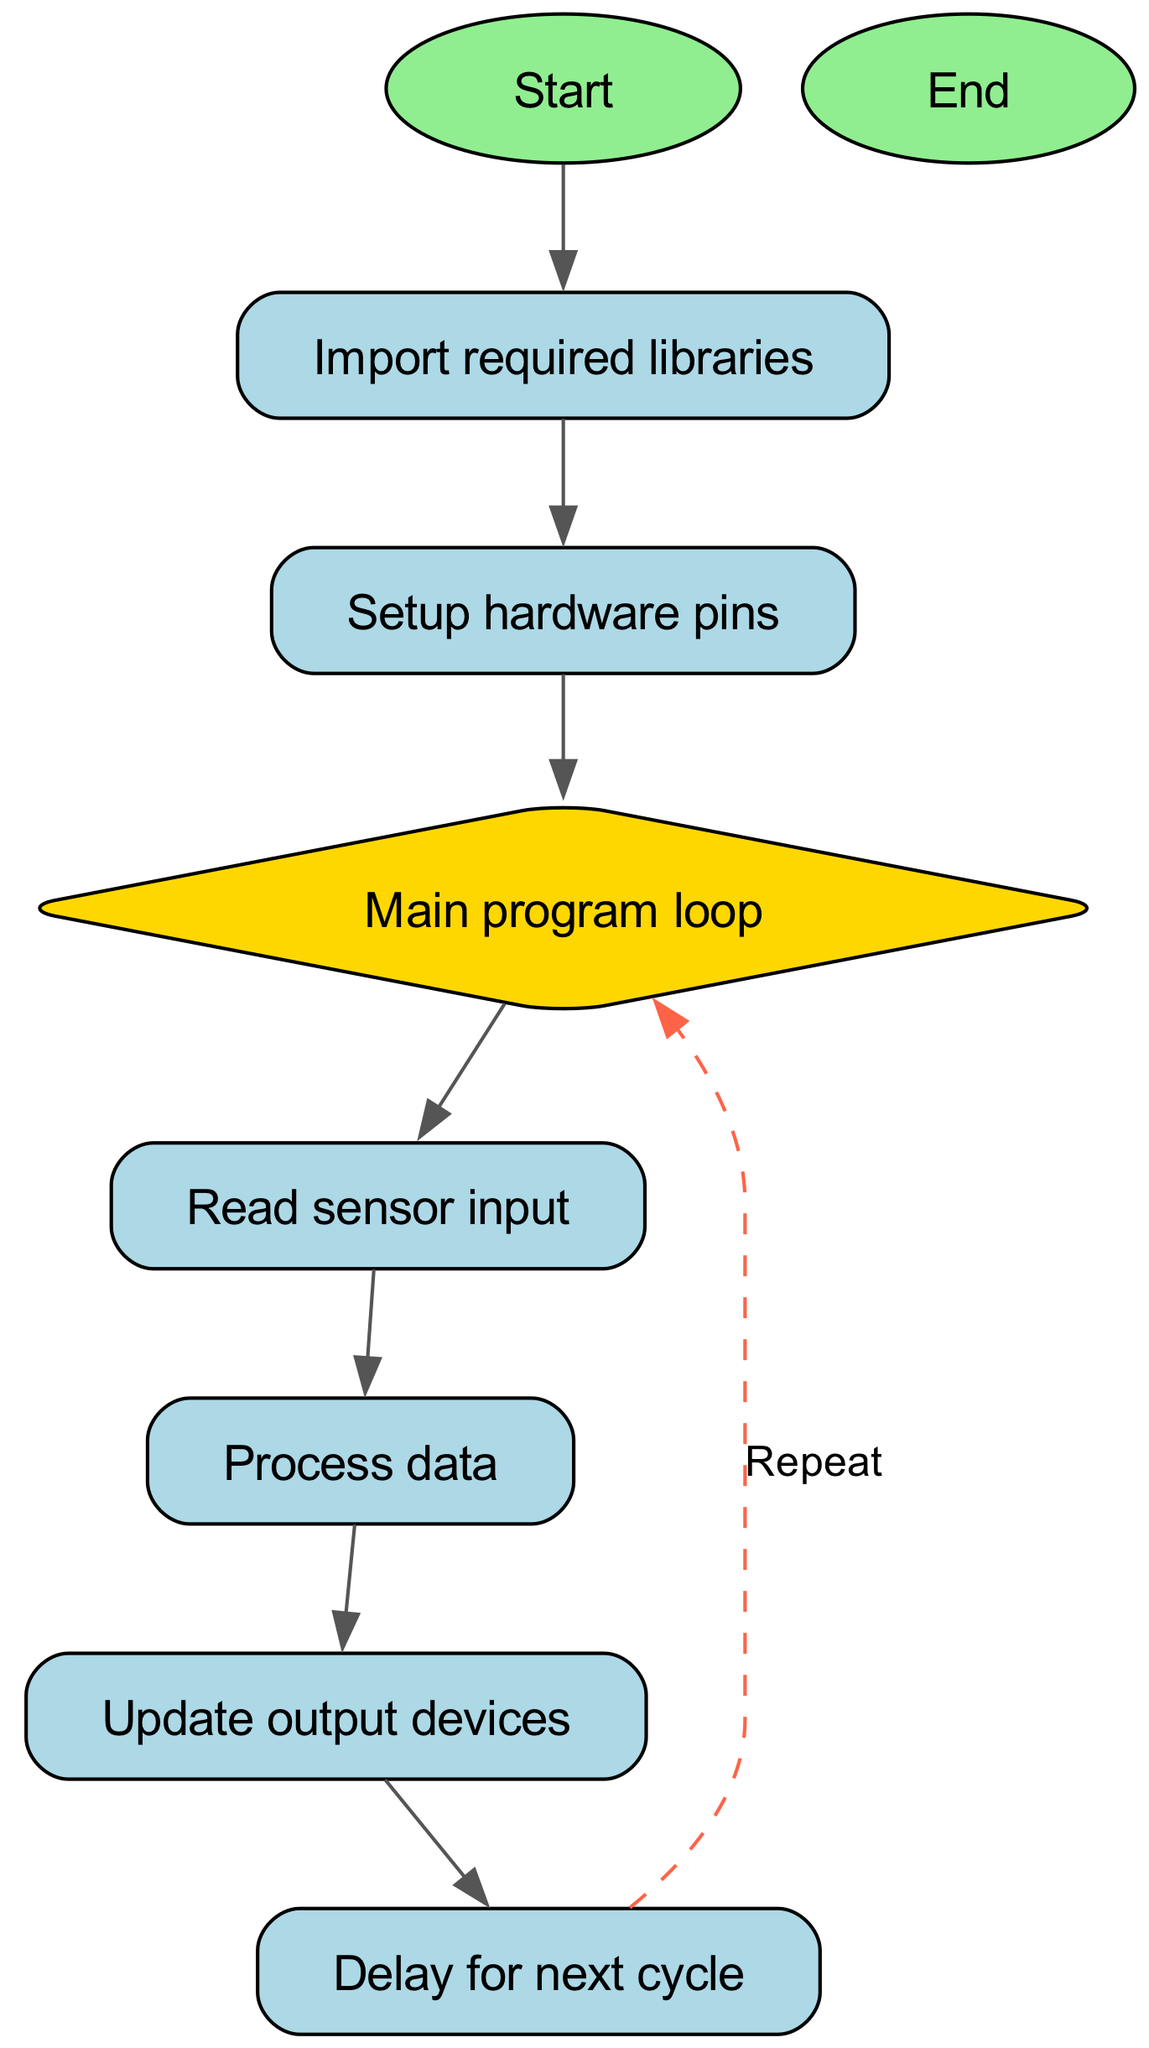What is the first step in the MicroPython program flow? The first step is represented by the node labeled "Start." It initiates the program flow before any libraries are utilized.
Answer: Start How many nodes are in the diagram? The diagram features a total of 9 nodes, as indicated in the provided node list.
Answer: 9 What comes after "Import required libraries"? The flow shows that after importing libraries, the program proceeds to the "Setup hardware pins" node, indicating the next action taken.
Answer: Setup hardware pins Which node acts as a decision point in the flowchart? The "Main program loop" is depicted as a diamond, which is commonly used to represent a decision-making point in flowcharts.
Answer: Main program loop What is the last action in the program flow? The last action shown before termination is represented by the node labeled "End," indicating the conclusion of the program's execution.
Answer: End What is the relationship between "Process data" and "Update output devices"? The diagram shows a direct connection from "Process data" to "Update output devices," indicating the sequential flow of actions where processed data is used to update outputs.
Answer: Direct connection What does the arrow labeled "Repeat" indicate? The "Repeat" label on the arrow from "Delay for next cycle" to "Main program loop" signifies that the program will loop back to the main loop after a delay, perpetuating the cycle.
Answer: Looping back Which node signifies a wait period in the program flow? The node labeled "Delay for next cycle" indicates that a waiting period occurs before the next action in the flowchart.
Answer: Delay for next cycle What is the relationship between "Read sensor input" and "Process data"? The diagram visually shows that after reading sensor input, the subsequent action is to process the gathered data, establishing a clear sequential relationship.
Answer: Sequential relationship 